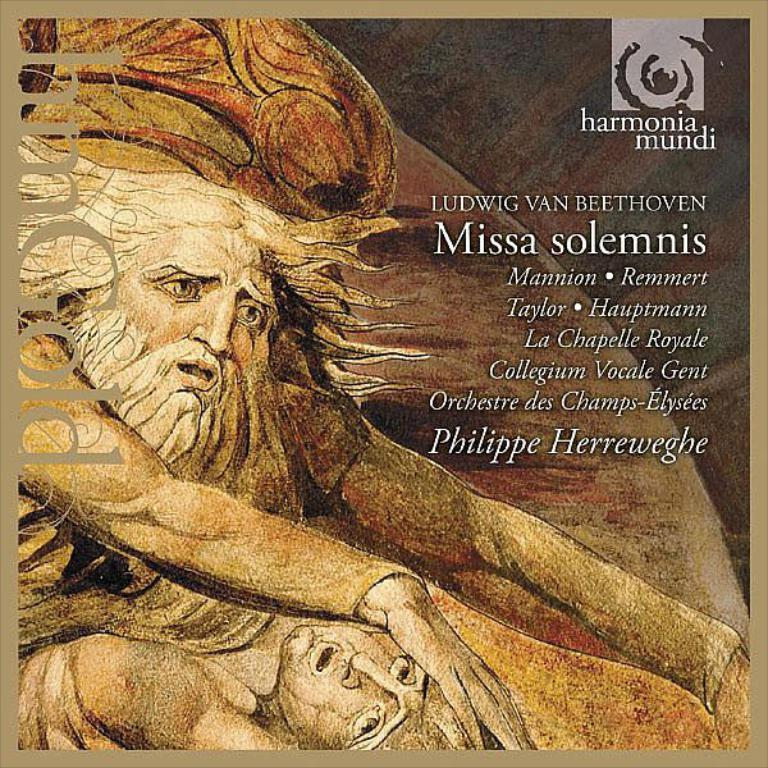What type of visual is depicted in the image? The image is a poster. How many people are featured in the poster? There are two people in the poster. What else can be found in the poster besides the people? There is text in the poster. Are the two people in the poster jumping in a pile of dirt while wearing suits? There is no information about jumping, dirt, or suits in the image, as it only features two people and text on a poster. 